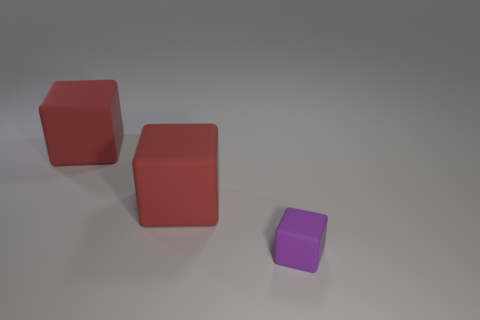How many objects are matte blocks behind the small rubber thing or blocks left of the purple rubber thing? 2 